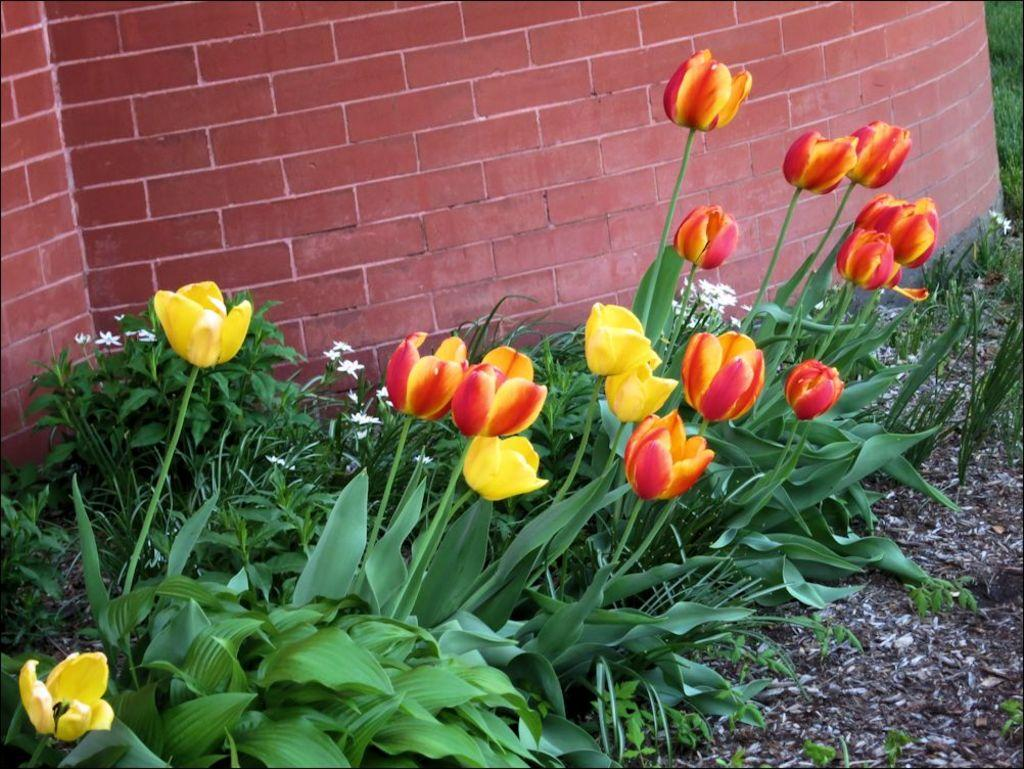What type of flowers are present in the image? There are tulip flower plants in the image. What can be seen behind the tulip flower plants? There is a red brick wall behind the tulip flower plants. How many chickens are sitting on the tulip flower plants in the image? There are no chickens present in the image; it only features tulip flower plants and a red brick wall. 